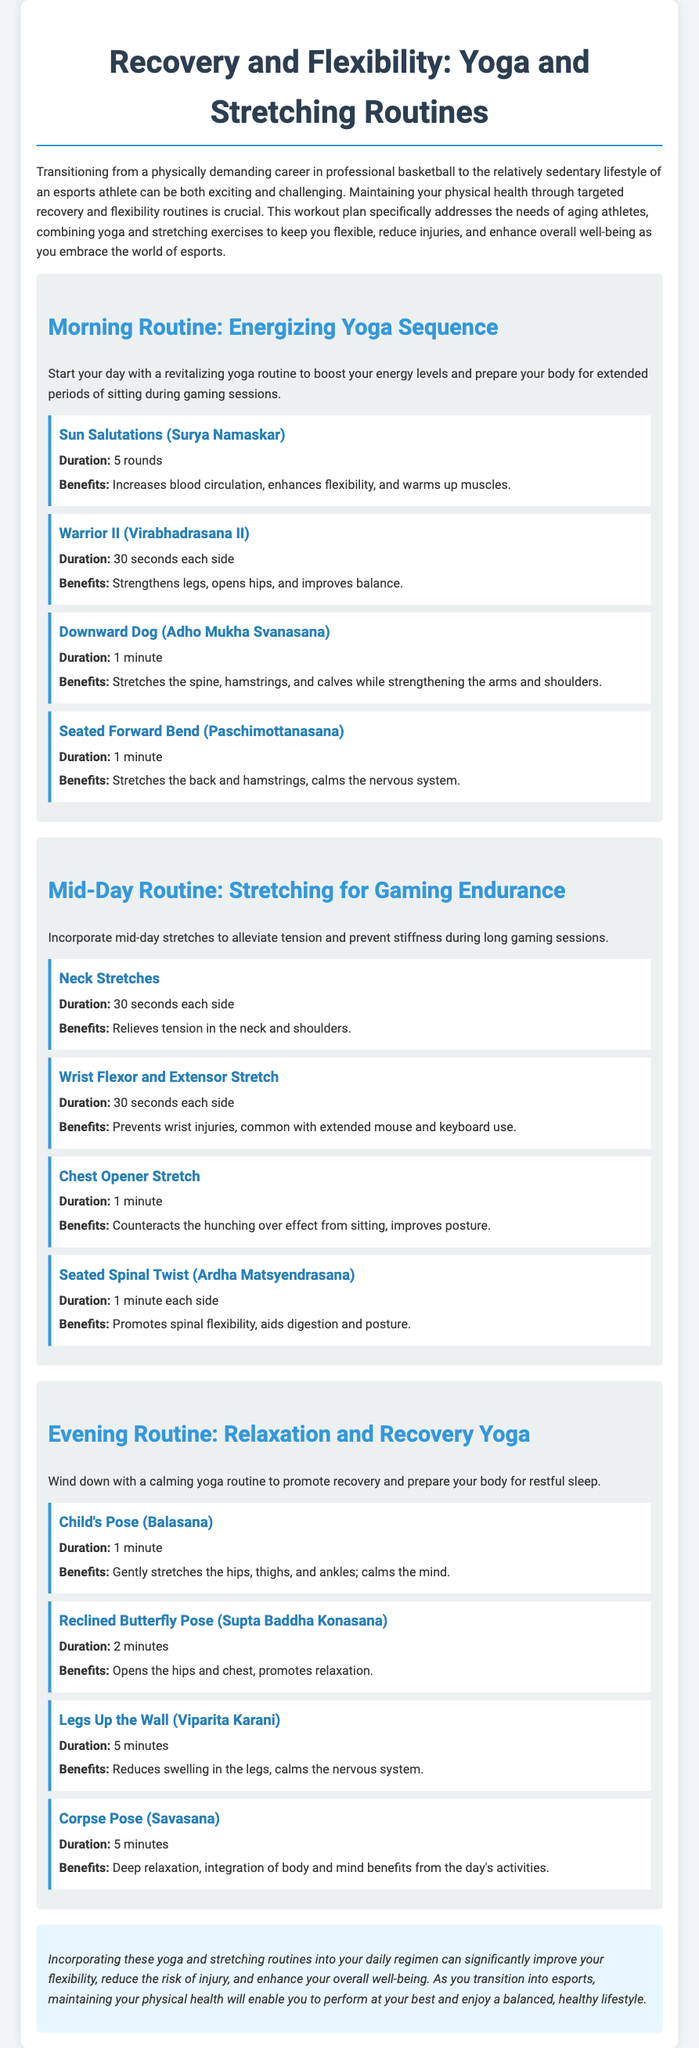What is the title of the document? The title of the document is stated at the top and gives a clear indication of its content, which is "Recovery and Flexibility: Yoga and Stretching Routines."
Answer: Recovery and Flexibility: Yoga and Stretching Routines How long should you hold the Downward Dog pose? The document specifies the duration for the Downward Dog pose, making it clear how long it should be held.
Answer: 1 minute What is one benefit of the Sun Salutations? The benefits of the Sun Salutations are listed in the document, indicating their positive effects on health.
Answer: Increases blood circulation How many rounds of the Sun Salutations are recommended? The document provides a specific number for the rounds of the Sun Salutations recommended in the morning routine.
Answer: 5 rounds What is the focus of the Mid-Day Routine? The document mentions the focus of the Mid-Day Routine specifically aimed at alleviating certain physical conditions during gaming.
Answer: Stretching for Gaming Endurance What pose is recommended for relaxation in the Evening Routine? The Evening Routine includes several poses, but one is specifically highlighted for relaxation.
Answer: Child's Pose What is the duration for the Legs Up the Wall pose? The document clearly states the recommended duration for the Legs Up the Wall pose in the Evening Routine.
Answer: 5 minutes Which exercise helps with wrist injuries? The document identifies a specific stretch that targets wrist injuries associated with prolonged use of gaming equipment.
Answer: Wrist Flexor and Extensor Stretch What is the purpose of the Evening Routine? The document summarizes the intent of the Evening Routine, focusing on the benefits for the body at the end of the day.
Answer: Relaxation and Recovery Yoga 